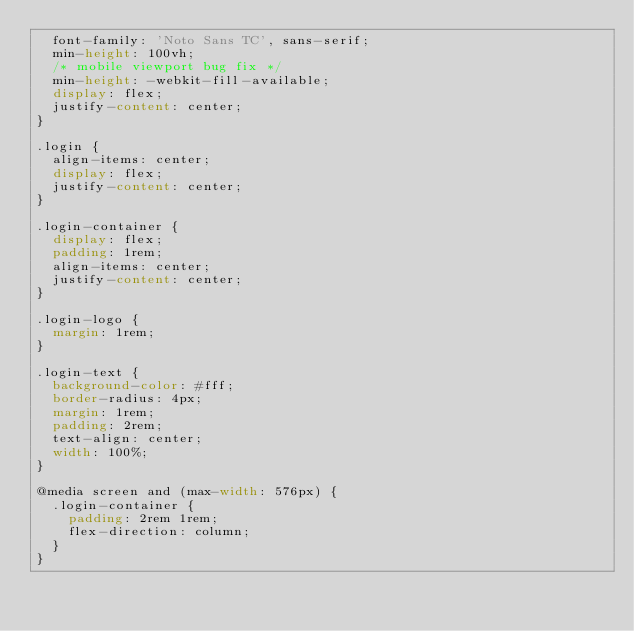<code> <loc_0><loc_0><loc_500><loc_500><_CSS_>  font-family: 'Noto Sans TC', sans-serif;
  min-height: 100vh;
  /* mobile viewport bug fix */
  min-height: -webkit-fill-available;
  display: flex;
  justify-content: center;
}

.login {
  align-items: center;
  display: flex;
  justify-content: center;
}

.login-container {
  display: flex;
  padding: 1rem;
  align-items: center;
  justify-content: center;
}

.login-logo {
  margin: 1rem;
}

.login-text {
  background-color: #fff;
  border-radius: 4px;
  margin: 1rem;
  padding: 2rem;
  text-align: center;
  width: 100%;
}

@media screen and (max-width: 576px) {
  .login-container {
    padding: 2rem 1rem;
    flex-direction: column;
  }
}
</code> 